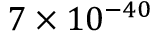Convert formula to latex. <formula><loc_0><loc_0><loc_500><loc_500>7 \times 1 0 ^ { - 4 0 }</formula> 